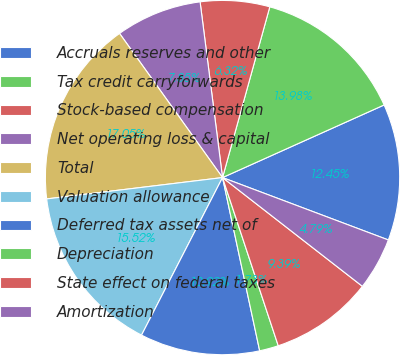Convert chart to OTSL. <chart><loc_0><loc_0><loc_500><loc_500><pie_chart><fcel>Accruals reserves and other<fcel>Tax credit carryforwards<fcel>Stock-based compensation<fcel>Net operating loss & capital<fcel>Total<fcel>Valuation allowance<fcel>Deferred tax assets net of<fcel>Depreciation<fcel>State effect on federal taxes<fcel>Amortization<nl><fcel>12.45%<fcel>13.98%<fcel>6.32%<fcel>7.85%<fcel>17.05%<fcel>15.52%<fcel>10.92%<fcel>1.73%<fcel>9.39%<fcel>4.79%<nl></chart> 